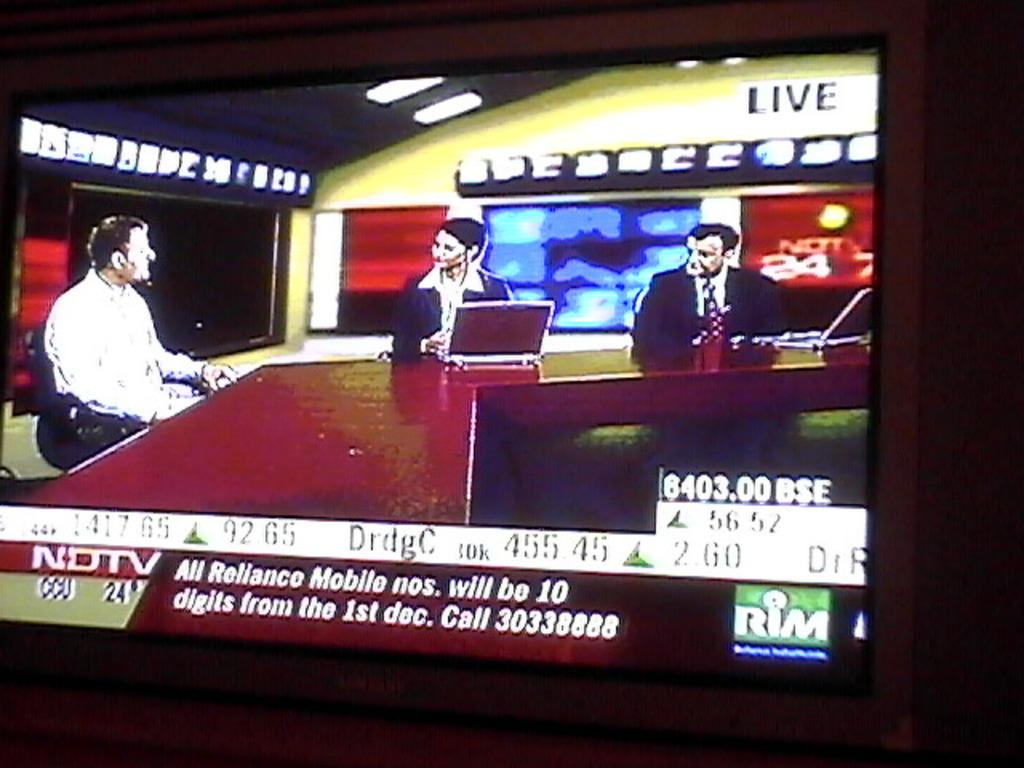<image>
Write a terse but informative summary of the picture. A NDTV crawl at the bottom of a TV screen has a phone number. 